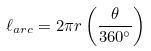Convert formula to latex. <formula><loc_0><loc_0><loc_500><loc_500>\ell _ { a r c } = 2 \pi r \left ( { \frac { \theta } { 3 6 0 ^ { \circ } } } \right )</formula> 